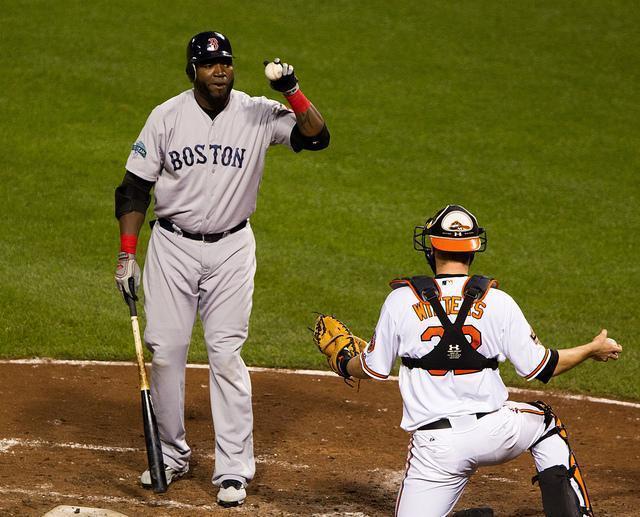How many people can you see?
Give a very brief answer. 2. How many people are wearing orange vests?
Give a very brief answer. 0. 